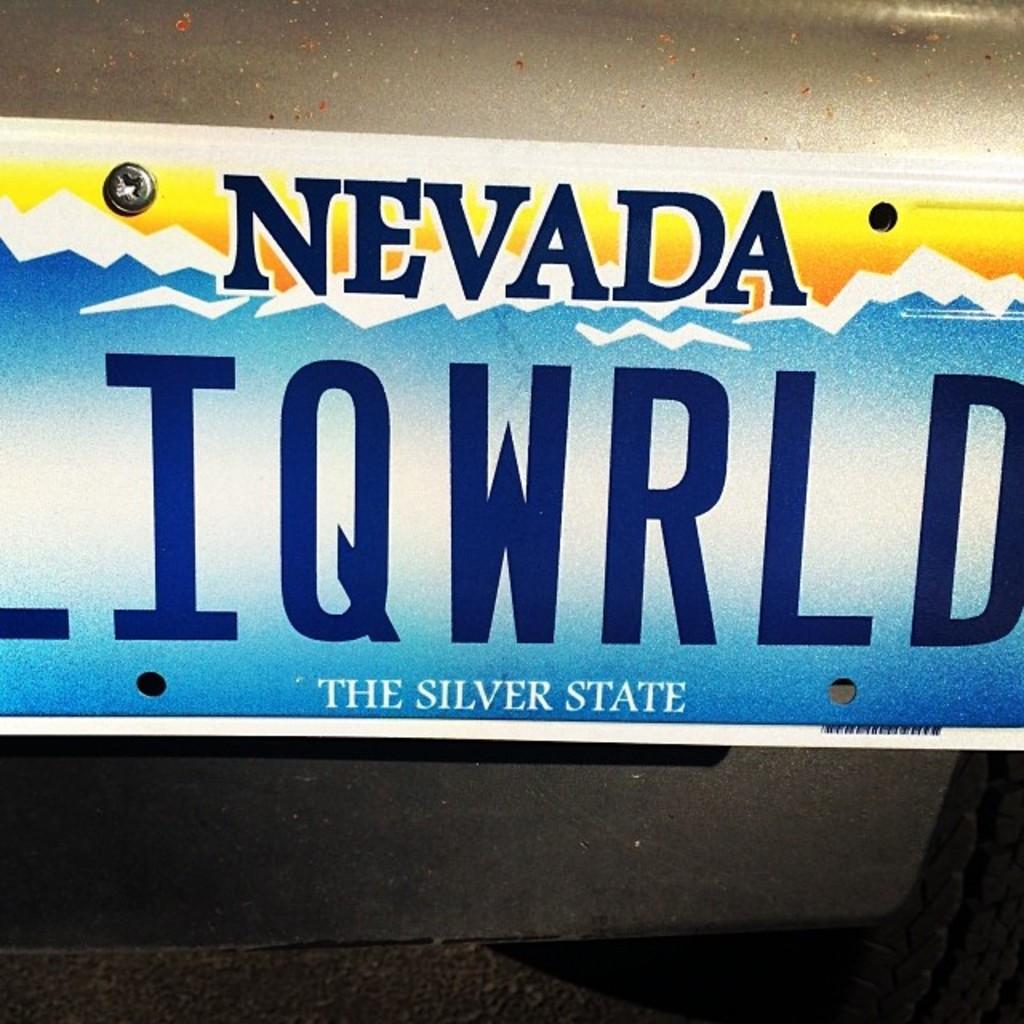Where is the tag from?
Ensure brevity in your answer.  Nevada. What type of state is this?
Make the answer very short. The silver state. 